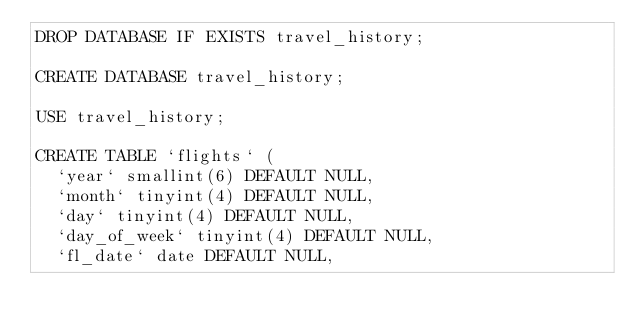<code> <loc_0><loc_0><loc_500><loc_500><_SQL_>DROP DATABASE IF EXISTS travel_history;

CREATE DATABASE travel_history;

USE travel_history;

CREATE TABLE `flights` (
  `year` smallint(6) DEFAULT NULL,
  `month` tinyint(4) DEFAULT NULL,
  `day` tinyint(4) DEFAULT NULL,
  `day_of_week` tinyint(4) DEFAULT NULL,
  `fl_date` date DEFAULT NULL,</code> 